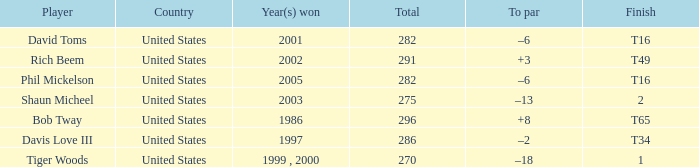What is the to par number of the person who won in 2003? –13. 